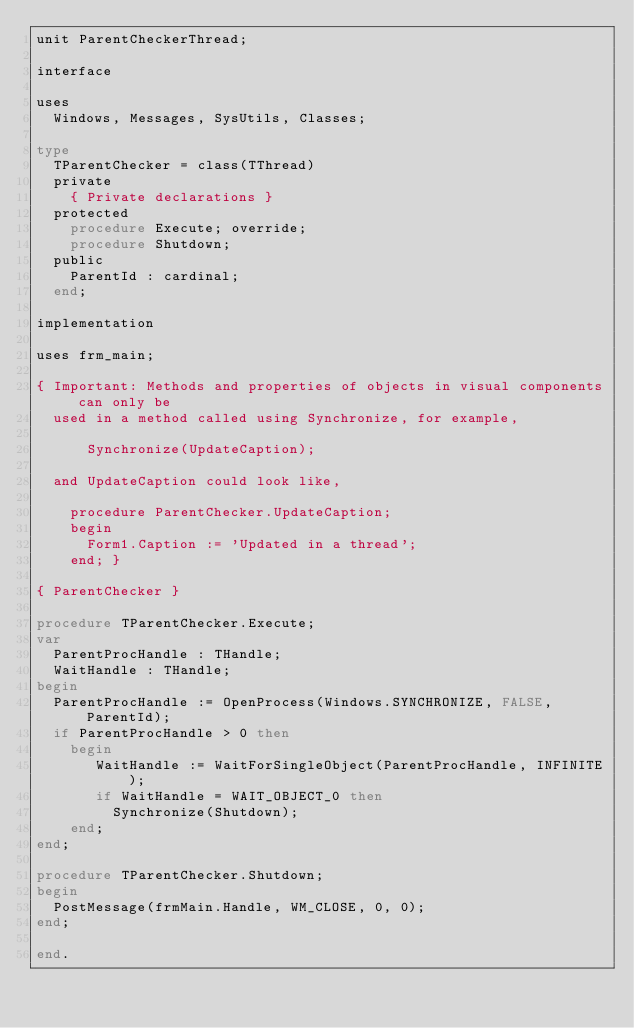Convert code to text. <code><loc_0><loc_0><loc_500><loc_500><_Pascal_>unit ParentCheckerThread;

interface

uses
  Windows, Messages, SysUtils, Classes;

type
  TParentChecker = class(TThread)
  private
    { Private declarations }
  protected
    procedure Execute; override;
    procedure Shutdown;
  public
    ParentId : cardinal;
  end;

implementation

uses frm_main;

{ Important: Methods and properties of objects in visual components can only be
  used in a method called using Synchronize, for example,

      Synchronize(UpdateCaption);

  and UpdateCaption could look like,

    procedure ParentChecker.UpdateCaption;
    begin
      Form1.Caption := 'Updated in a thread';
    end; }

{ ParentChecker }

procedure TParentChecker.Execute;
var
  ParentProcHandle : THandle;
  WaitHandle : THandle;
begin
  ParentProcHandle := OpenProcess(Windows.SYNCHRONIZE, FALSE, ParentId);
  if ParentProcHandle > 0 then
    begin
       WaitHandle := WaitForSingleObject(ParentProcHandle, INFINITE);
       if WaitHandle = WAIT_OBJECT_0 then
         Synchronize(Shutdown);
    end;
end;

procedure TParentChecker.Shutdown;
begin
  PostMessage(frmMain.Handle, WM_CLOSE, 0, 0);
end;

end.
</code> 